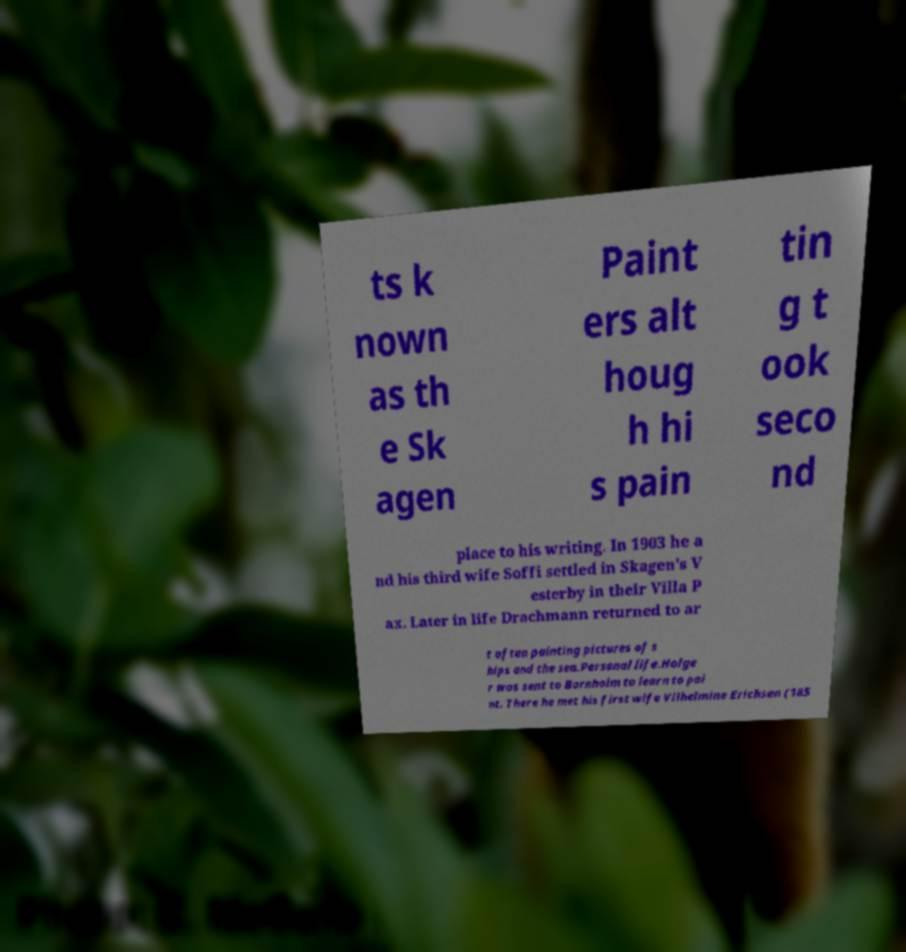Could you assist in decoding the text presented in this image and type it out clearly? ts k nown as th e Sk agen Paint ers alt houg h hi s pain tin g t ook seco nd place to his writing. In 1903 he a nd his third wife Soffi settled in Skagen's V esterby in their Villa P ax. Later in life Drachmann returned to ar t often painting pictures of s hips and the sea.Personal life.Holge r was sent to Bornholm to learn to pai nt. There he met his first wife Vilhelmine Erichsen (185 